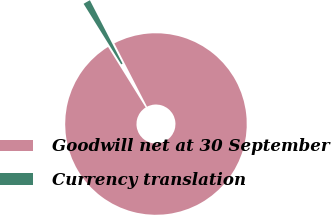Convert chart to OTSL. <chart><loc_0><loc_0><loc_500><loc_500><pie_chart><fcel>Goodwill net at 30 September<fcel>Currency translation<nl><fcel>98.73%<fcel>1.27%<nl></chart> 